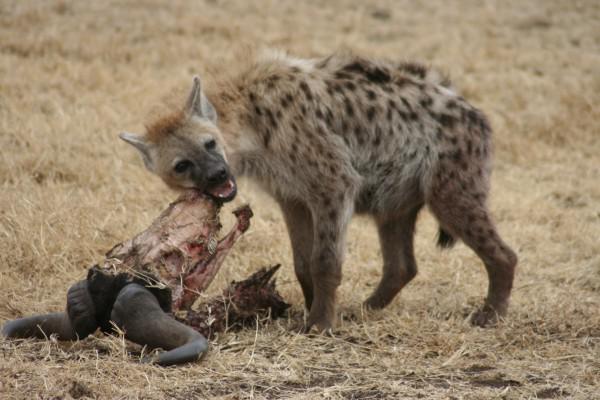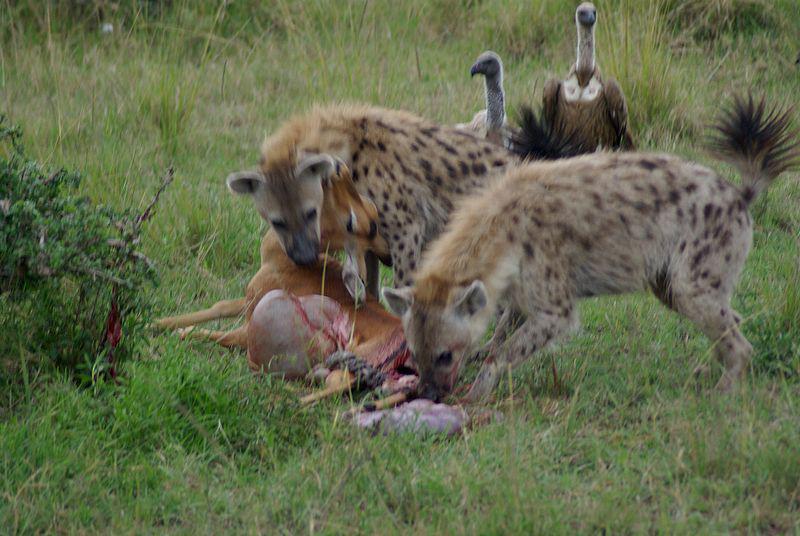The first image is the image on the left, the second image is the image on the right. Evaluate the accuracy of this statement regarding the images: "There's no more than two hyenas in the left image.". Is it true? Answer yes or no. Yes. The first image is the image on the left, the second image is the image on the right. Analyze the images presented: Is the assertion "An image shows no more than two hyenas standing with the carcass of a leopard-type spotted cat." valid? Answer yes or no. No. 